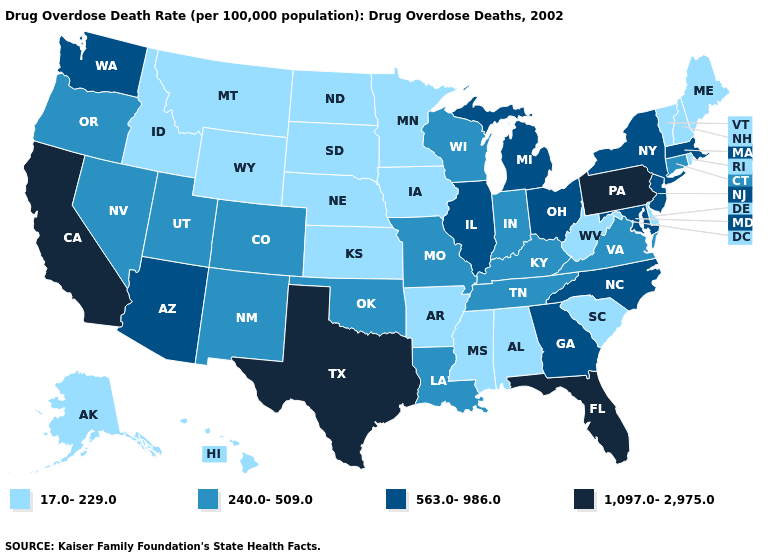Does the map have missing data?
Short answer required. No. Among the states that border New Hampshire , does Massachusetts have the lowest value?
Be succinct. No. What is the value of New Mexico?
Be succinct. 240.0-509.0. Does Maine have the lowest value in the Northeast?
Keep it brief. Yes. Does the first symbol in the legend represent the smallest category?
Quick response, please. Yes. Name the states that have a value in the range 563.0-986.0?
Keep it brief. Arizona, Georgia, Illinois, Maryland, Massachusetts, Michigan, New Jersey, New York, North Carolina, Ohio, Washington. What is the lowest value in states that border New York?
Write a very short answer. 17.0-229.0. What is the highest value in the USA?
Give a very brief answer. 1,097.0-2,975.0. What is the value of West Virginia?
Short answer required. 17.0-229.0. What is the value of Colorado?
Write a very short answer. 240.0-509.0. What is the value of Oklahoma?
Concise answer only. 240.0-509.0. Which states have the lowest value in the Northeast?
Answer briefly. Maine, New Hampshire, Rhode Island, Vermont. Does Rhode Island have the lowest value in the USA?
Short answer required. Yes. Name the states that have a value in the range 563.0-986.0?
Quick response, please. Arizona, Georgia, Illinois, Maryland, Massachusetts, Michigan, New Jersey, New York, North Carolina, Ohio, Washington. 